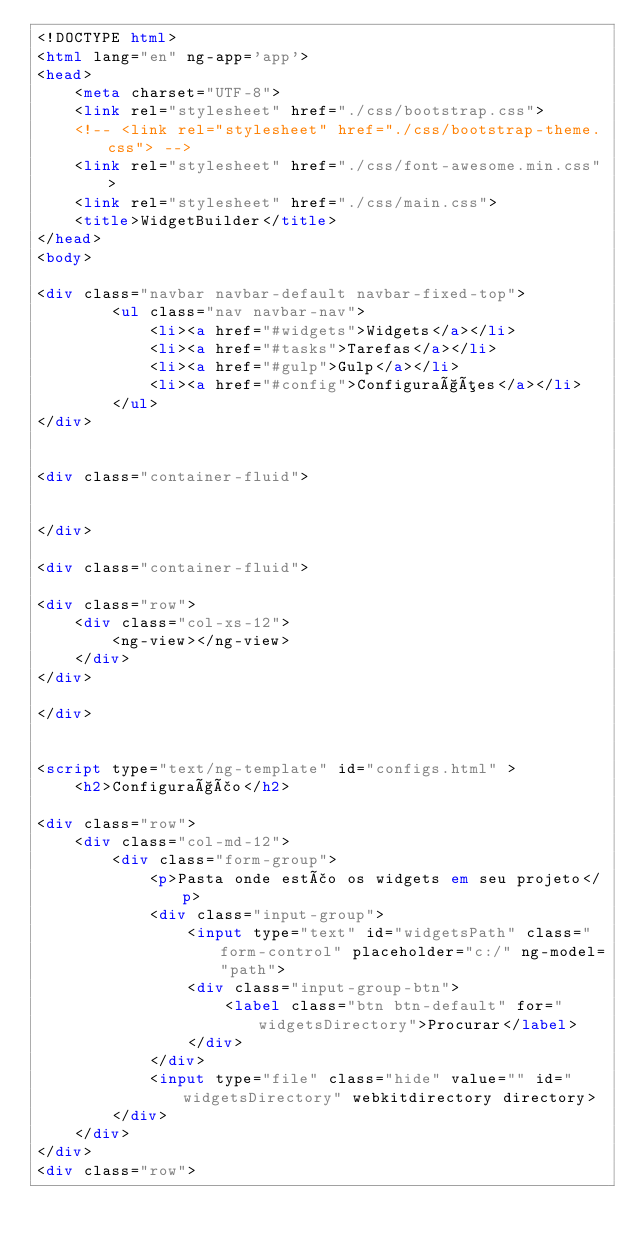Convert code to text. <code><loc_0><loc_0><loc_500><loc_500><_HTML_><!DOCTYPE html>
<html lang="en" ng-app='app'>
<head>
    <meta charset="UTF-8">
    <link rel="stylesheet" href="./css/bootstrap.css">
    <!-- <link rel="stylesheet" href="./css/bootstrap-theme.css"> -->
    <link rel="stylesheet" href="./css/font-awesome.min.css">
    <link rel="stylesheet" href="./css/main.css">
    <title>WidgetBuilder</title>
</head>
<body>

<div class="navbar navbar-default navbar-fixed-top">
        <ul class="nav navbar-nav">
            <li><a href="#widgets">Widgets</a></li>
            <li><a href="#tasks">Tarefas</a></li>
            <li><a href="#gulp">Gulp</a></li>
            <li><a href="#config">Configurações</a></li>
        </ul>
</div>


<div class="container-fluid">
    
    
</div>

<div class="container-fluid">
    
<div class="row">
    <div class="col-xs-12">
        <ng-view></ng-view>
    </div>
</div>

</div>

    
<script type="text/ng-template" id="configs.html" >
    <h2>Configuração</h2>

<div class="row">
    <div class="col-md-12">
        <div class="form-group">
            <p>Pasta onde estão os widgets em seu projeto</p>
            <div class="input-group">
                <input type="text" id="widgetsPath" class="form-control" placeholder="c:/" ng-model="path">
                <div class="input-group-btn">
                    <label class="btn btn-default" for="widgetsDirectory">Procurar</label>
                </div>
            </div>
            <input type="file" class="hide" value="" id="widgetsDirectory" webkitdirectory directory>
        </div>
    </div>
</div>
<div class="row"></code> 